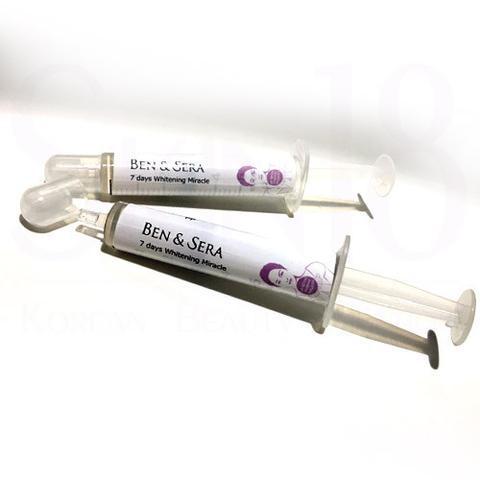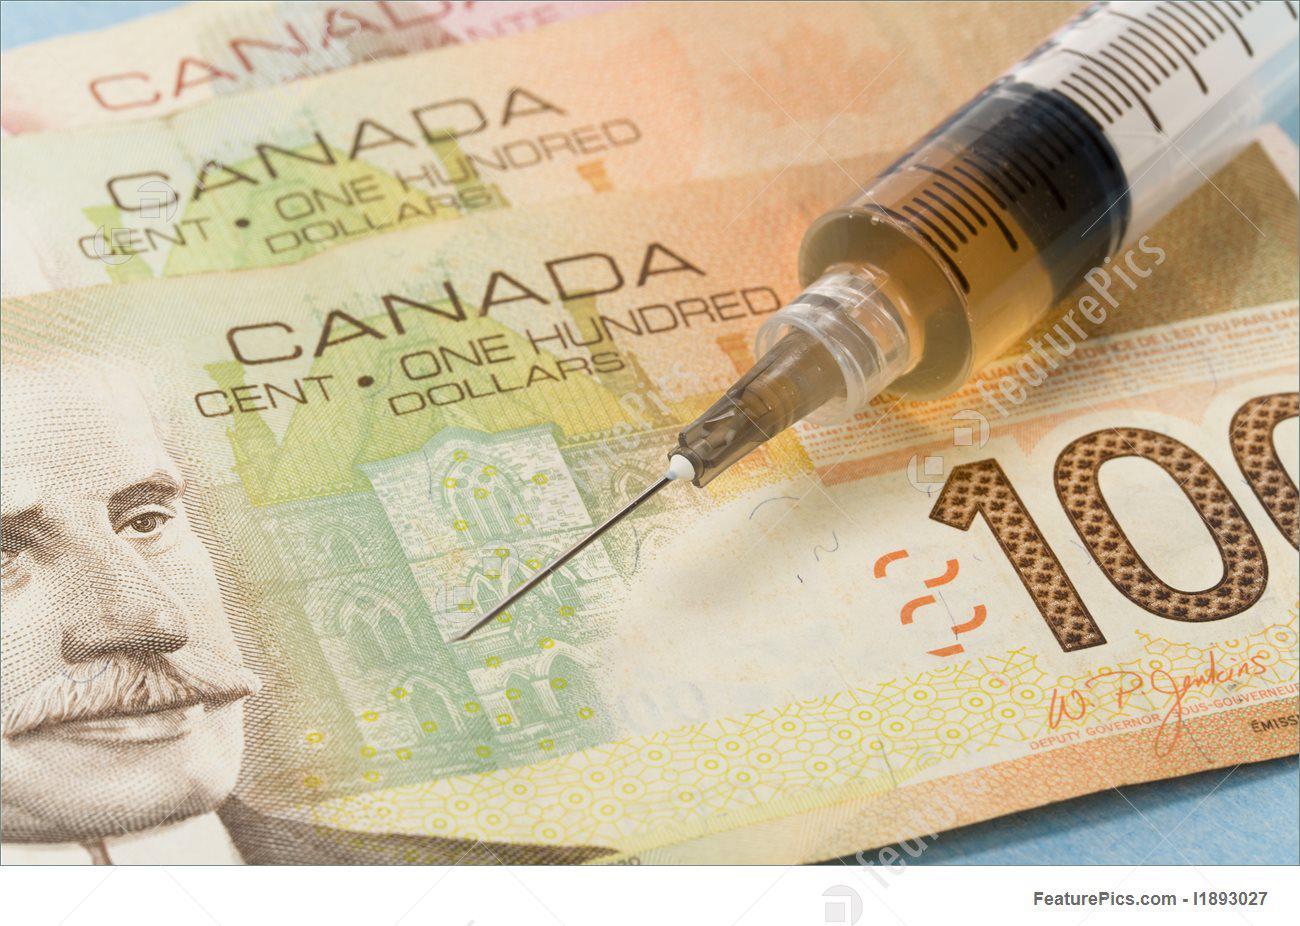The first image is the image on the left, the second image is the image on the right. Analyze the images presented: Is the assertion "The right image contains paper money and a syringe." valid? Answer yes or no. Yes. The first image is the image on the left, the second image is the image on the right. For the images displayed, is the sentence "American money is visible in one of the images." factually correct? Answer yes or no. No. 